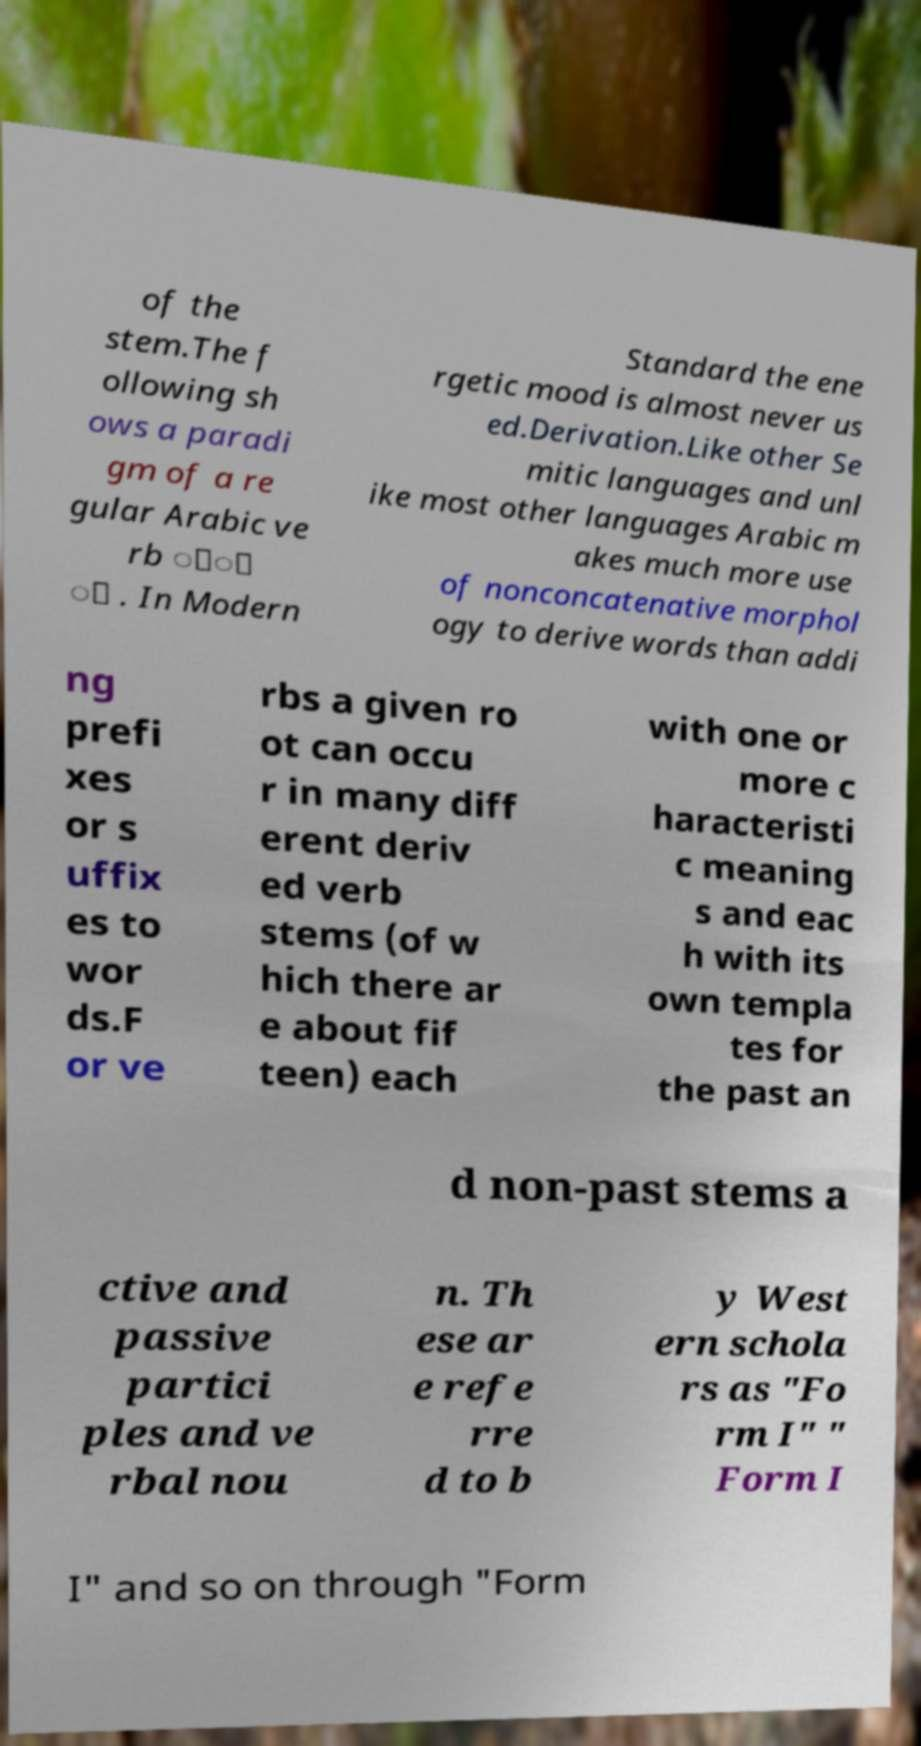Please identify and transcribe the text found in this image. of the stem.The f ollowing sh ows a paradi gm of a re gular Arabic ve rb ََ َ . In Modern Standard the ene rgetic mood is almost never us ed.Derivation.Like other Se mitic languages and unl ike most other languages Arabic m akes much more use of nonconcatenative morphol ogy to derive words than addi ng prefi xes or s uffix es to wor ds.F or ve rbs a given ro ot can occu r in many diff erent deriv ed verb stems (of w hich there ar e about fif teen) each with one or more c haracteristi c meaning s and eac h with its own templa tes for the past an d non-past stems a ctive and passive partici ples and ve rbal nou n. Th ese ar e refe rre d to b y West ern schola rs as "Fo rm I" " Form I I" and so on through "Form 